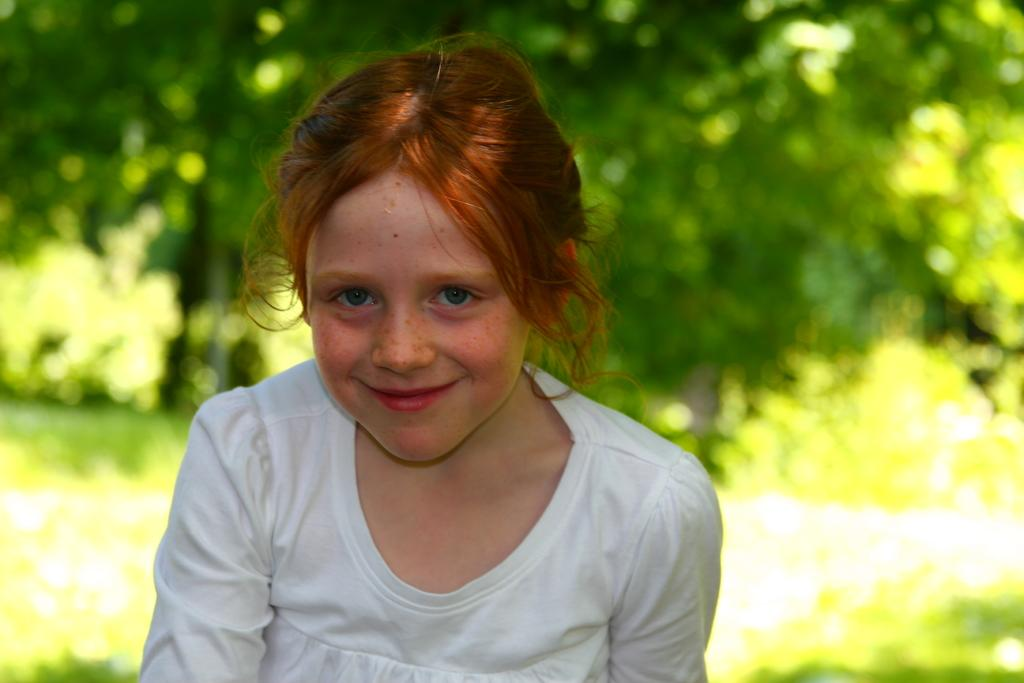Who is the main subject in the image? There is a small girl in the image. What is the girl doing in the image? The girl is sitting. What is the girl's facial expression in the image? The girl is smiling. What can be seen in the background of the image? There are green color trees in the background of the image. How many beds are visible in the image? There are no beds present in the image. What type of ocean can be seen in the image? There is no ocean present in the image. 